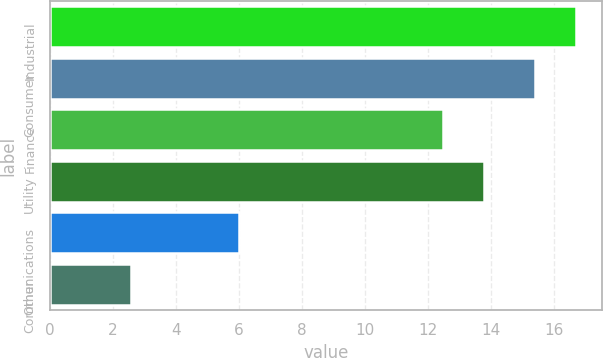Convert chart. <chart><loc_0><loc_0><loc_500><loc_500><bar_chart><fcel>Industrial<fcel>Consumer<fcel>Finance<fcel>Utility<fcel>Communications<fcel>Other<nl><fcel>16.7<fcel>15.4<fcel>12.5<fcel>13.8<fcel>6<fcel>2.6<nl></chart> 